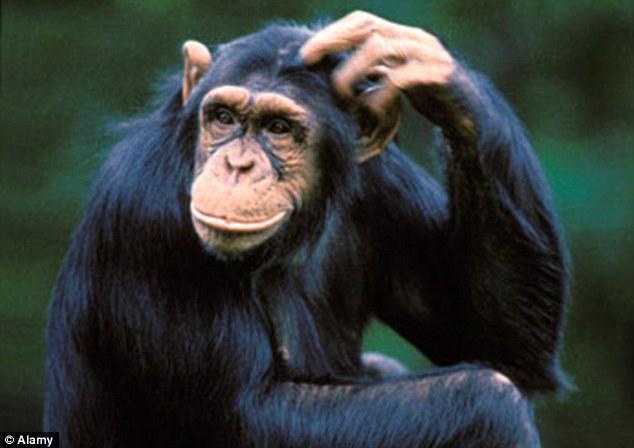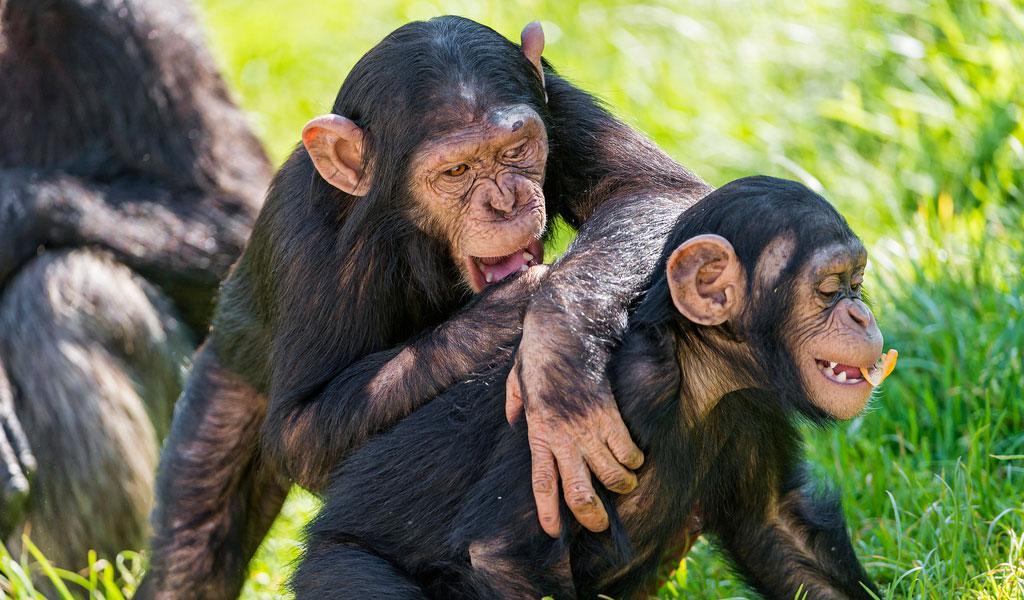The first image is the image on the left, the second image is the image on the right. Assess this claim about the two images: "The left photo contains a single chimp.". Correct or not? Answer yes or no. Yes. 